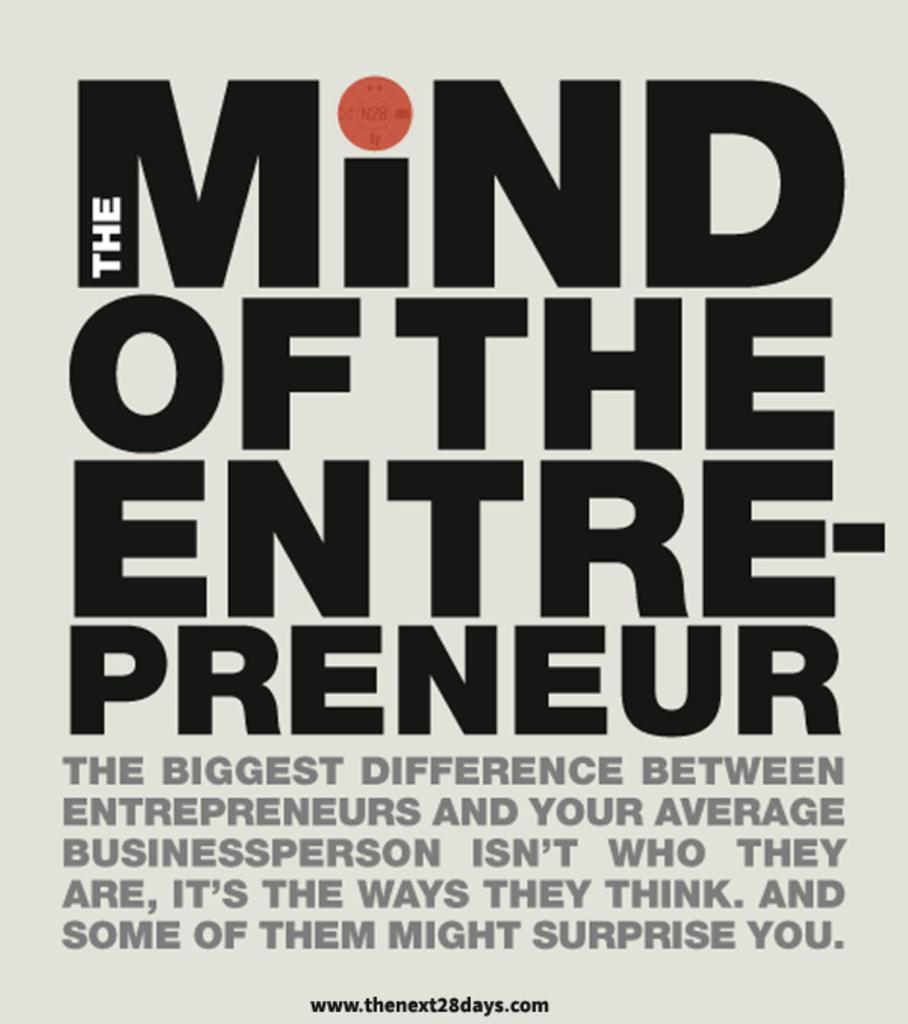What is present in the image that contains information or a message? There is a poster in the image. What can be found on the poster in the image? There is text printed on the poster. Can you tell me where the doctor is standing in the image? There is no doctor present in the image; it only contains a poster with text. Is there a stream visible in the image? There is no stream present in the image; it only contains a poster with text. 